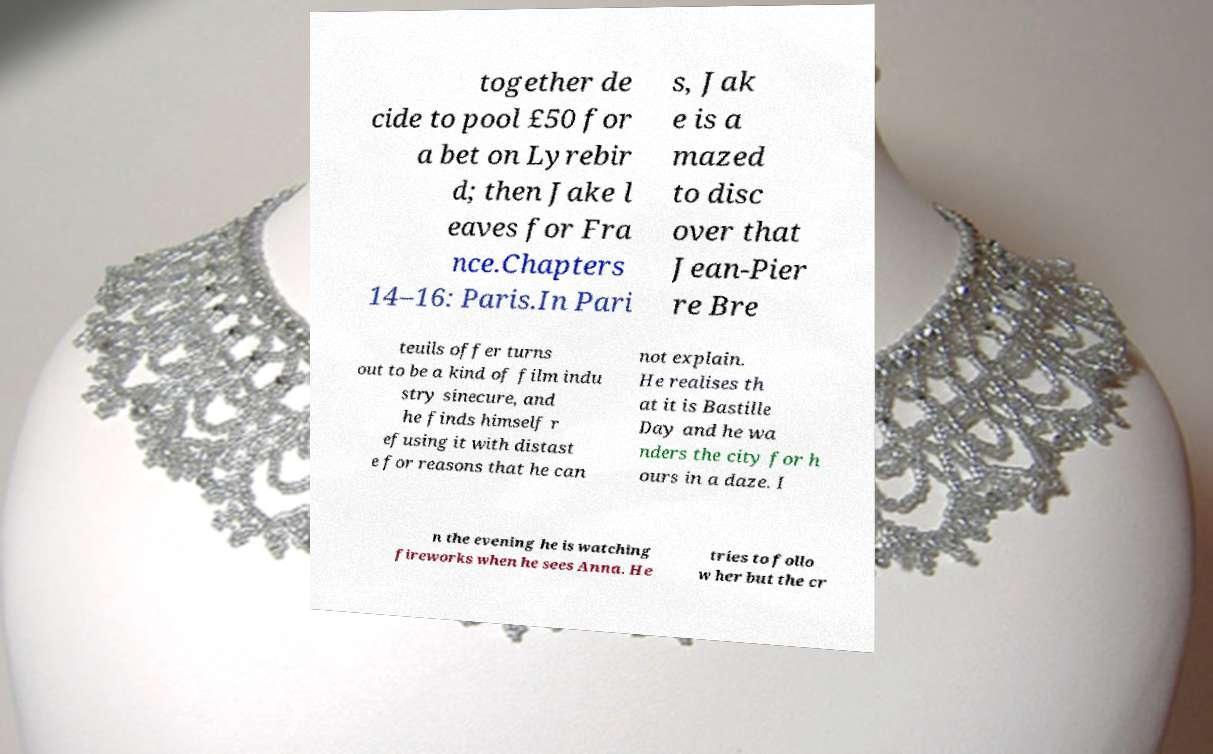Can you read and provide the text displayed in the image?This photo seems to have some interesting text. Can you extract and type it out for me? together de cide to pool £50 for a bet on Lyrebir d; then Jake l eaves for Fra nce.Chapters 14–16: Paris.In Pari s, Jak e is a mazed to disc over that Jean-Pier re Bre teuils offer turns out to be a kind of film indu stry sinecure, and he finds himself r efusing it with distast e for reasons that he can not explain. He realises th at it is Bastille Day and he wa nders the city for h ours in a daze. I n the evening he is watching fireworks when he sees Anna. He tries to follo w her but the cr 